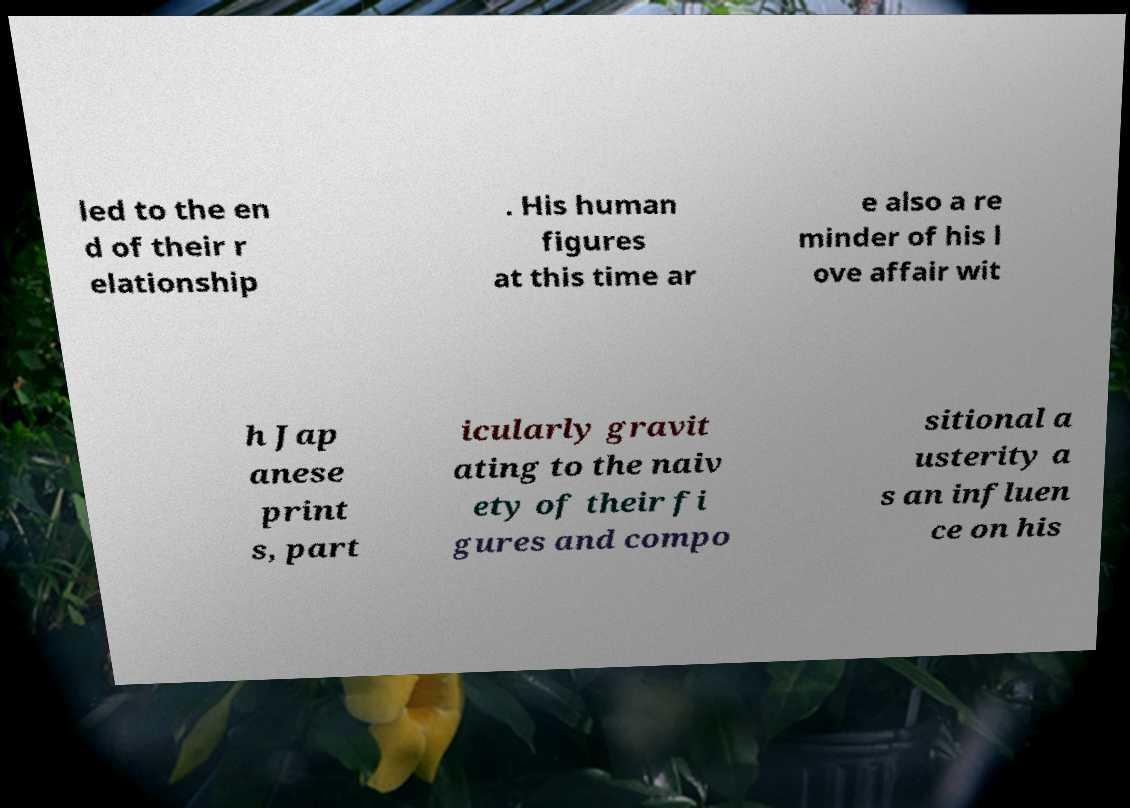What messages or text are displayed in this image? I need them in a readable, typed format. led to the en d of their r elationship . His human figures at this time ar e also a re minder of his l ove affair wit h Jap anese print s, part icularly gravit ating to the naiv ety of their fi gures and compo sitional a usterity a s an influen ce on his 